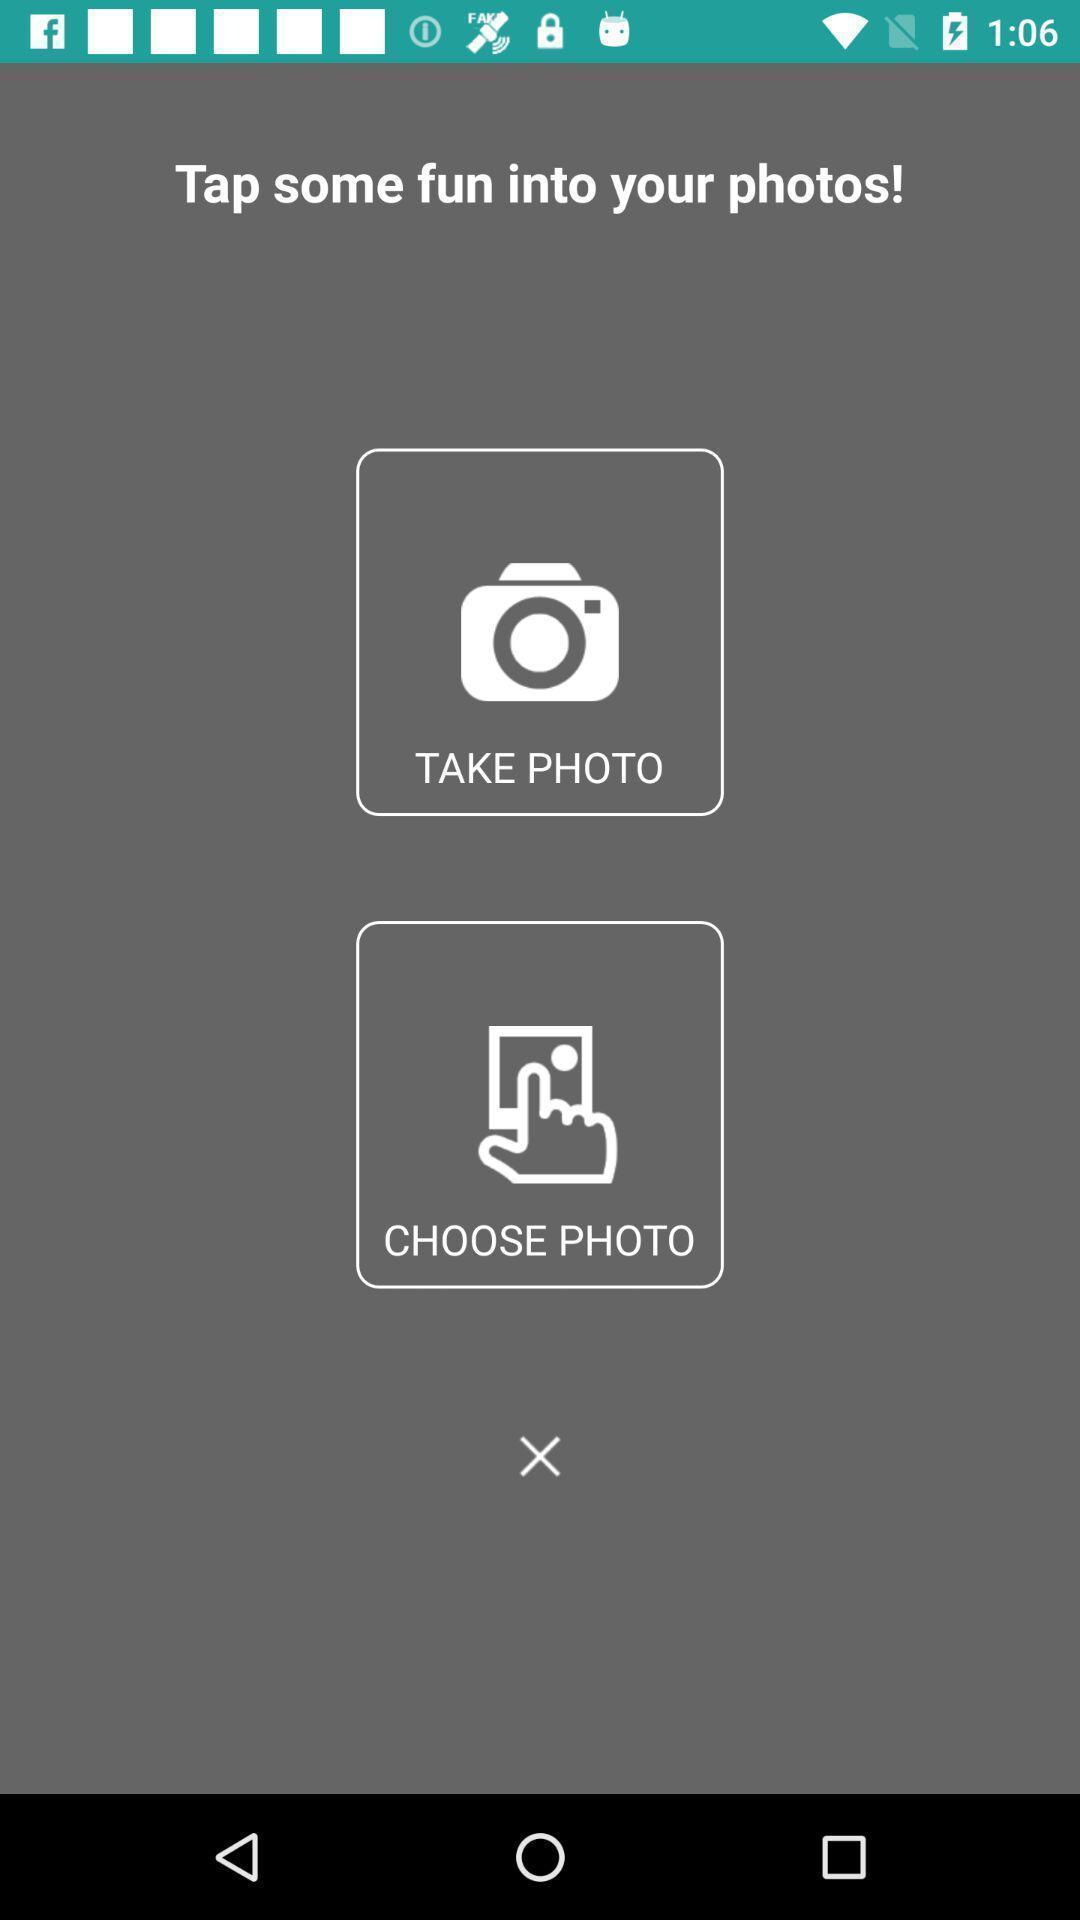What can you discern from this picture? Screen page displaying cancel icon. 